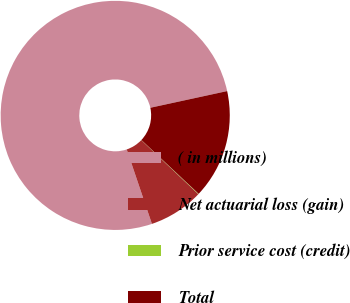<chart> <loc_0><loc_0><loc_500><loc_500><pie_chart><fcel>( in millions)<fcel>Net actuarial loss (gain)<fcel>Prior service cost (credit)<fcel>Total<nl><fcel>76.79%<fcel>7.74%<fcel>0.06%<fcel>15.41%<nl></chart> 